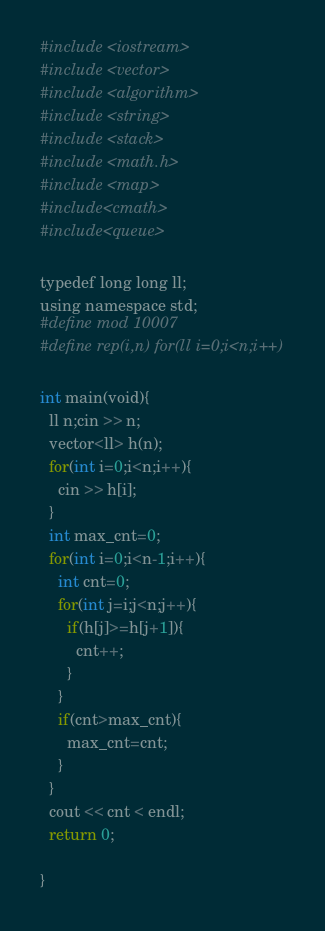Convert code to text. <code><loc_0><loc_0><loc_500><loc_500><_Python_>#include <iostream>
#include <vector>
#include <algorithm>
#include <string>
#include <stack>
#include <math.h>
#include <map>
#include<cmath>
#include<queue>

typedef long long ll;
using namespace std;
#define mod 10007
#define rep(i,n) for(ll i=0;i<n;i++)

int main(void){
  ll n;cin >> n;
  vector<ll> h(n);
  for(int i=0;i<n;i++){
    cin >> h[i];
  }
  int max_cnt=0;
  for(int i=0;i<n-1;i++){
    int cnt=0;
    for(int j=i;j<n;j++){
      if(h[j]>=h[j+1]){
        cnt++;
      }
    }
    if(cnt>max_cnt){
      max_cnt=cnt;
    }
  }
  cout << cnt < endl;
  return 0;

}
</code> 